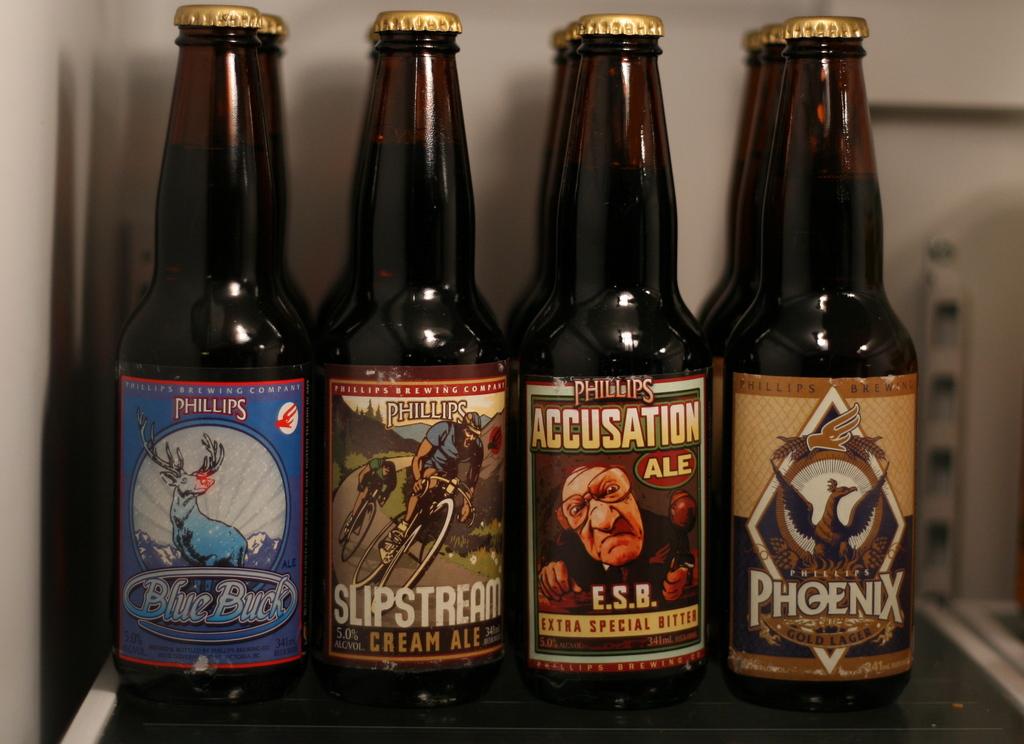What is one of the brands of beer in the middle?
Provide a succinct answer. Phillips. What mythical beast is the far right bottle named after?
Provide a short and direct response. Phoenix. 